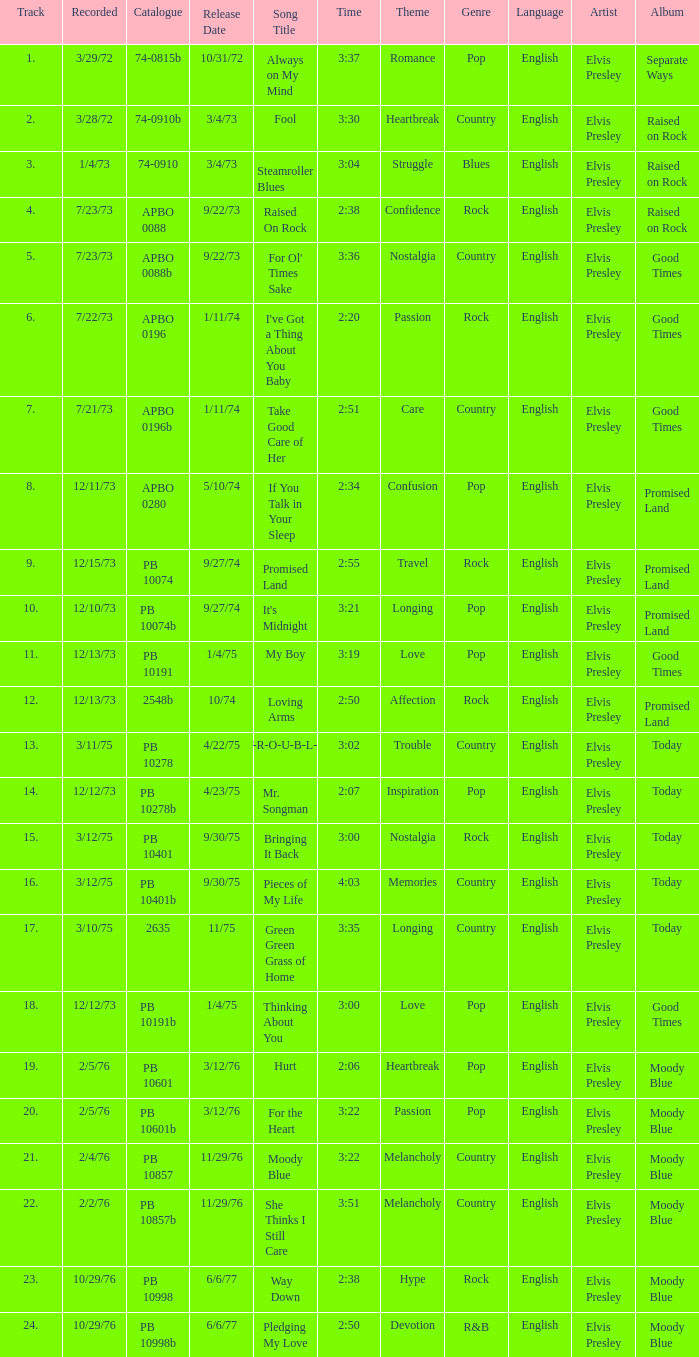Tell me the track that has the catalogue of apbo 0280 8.0. 